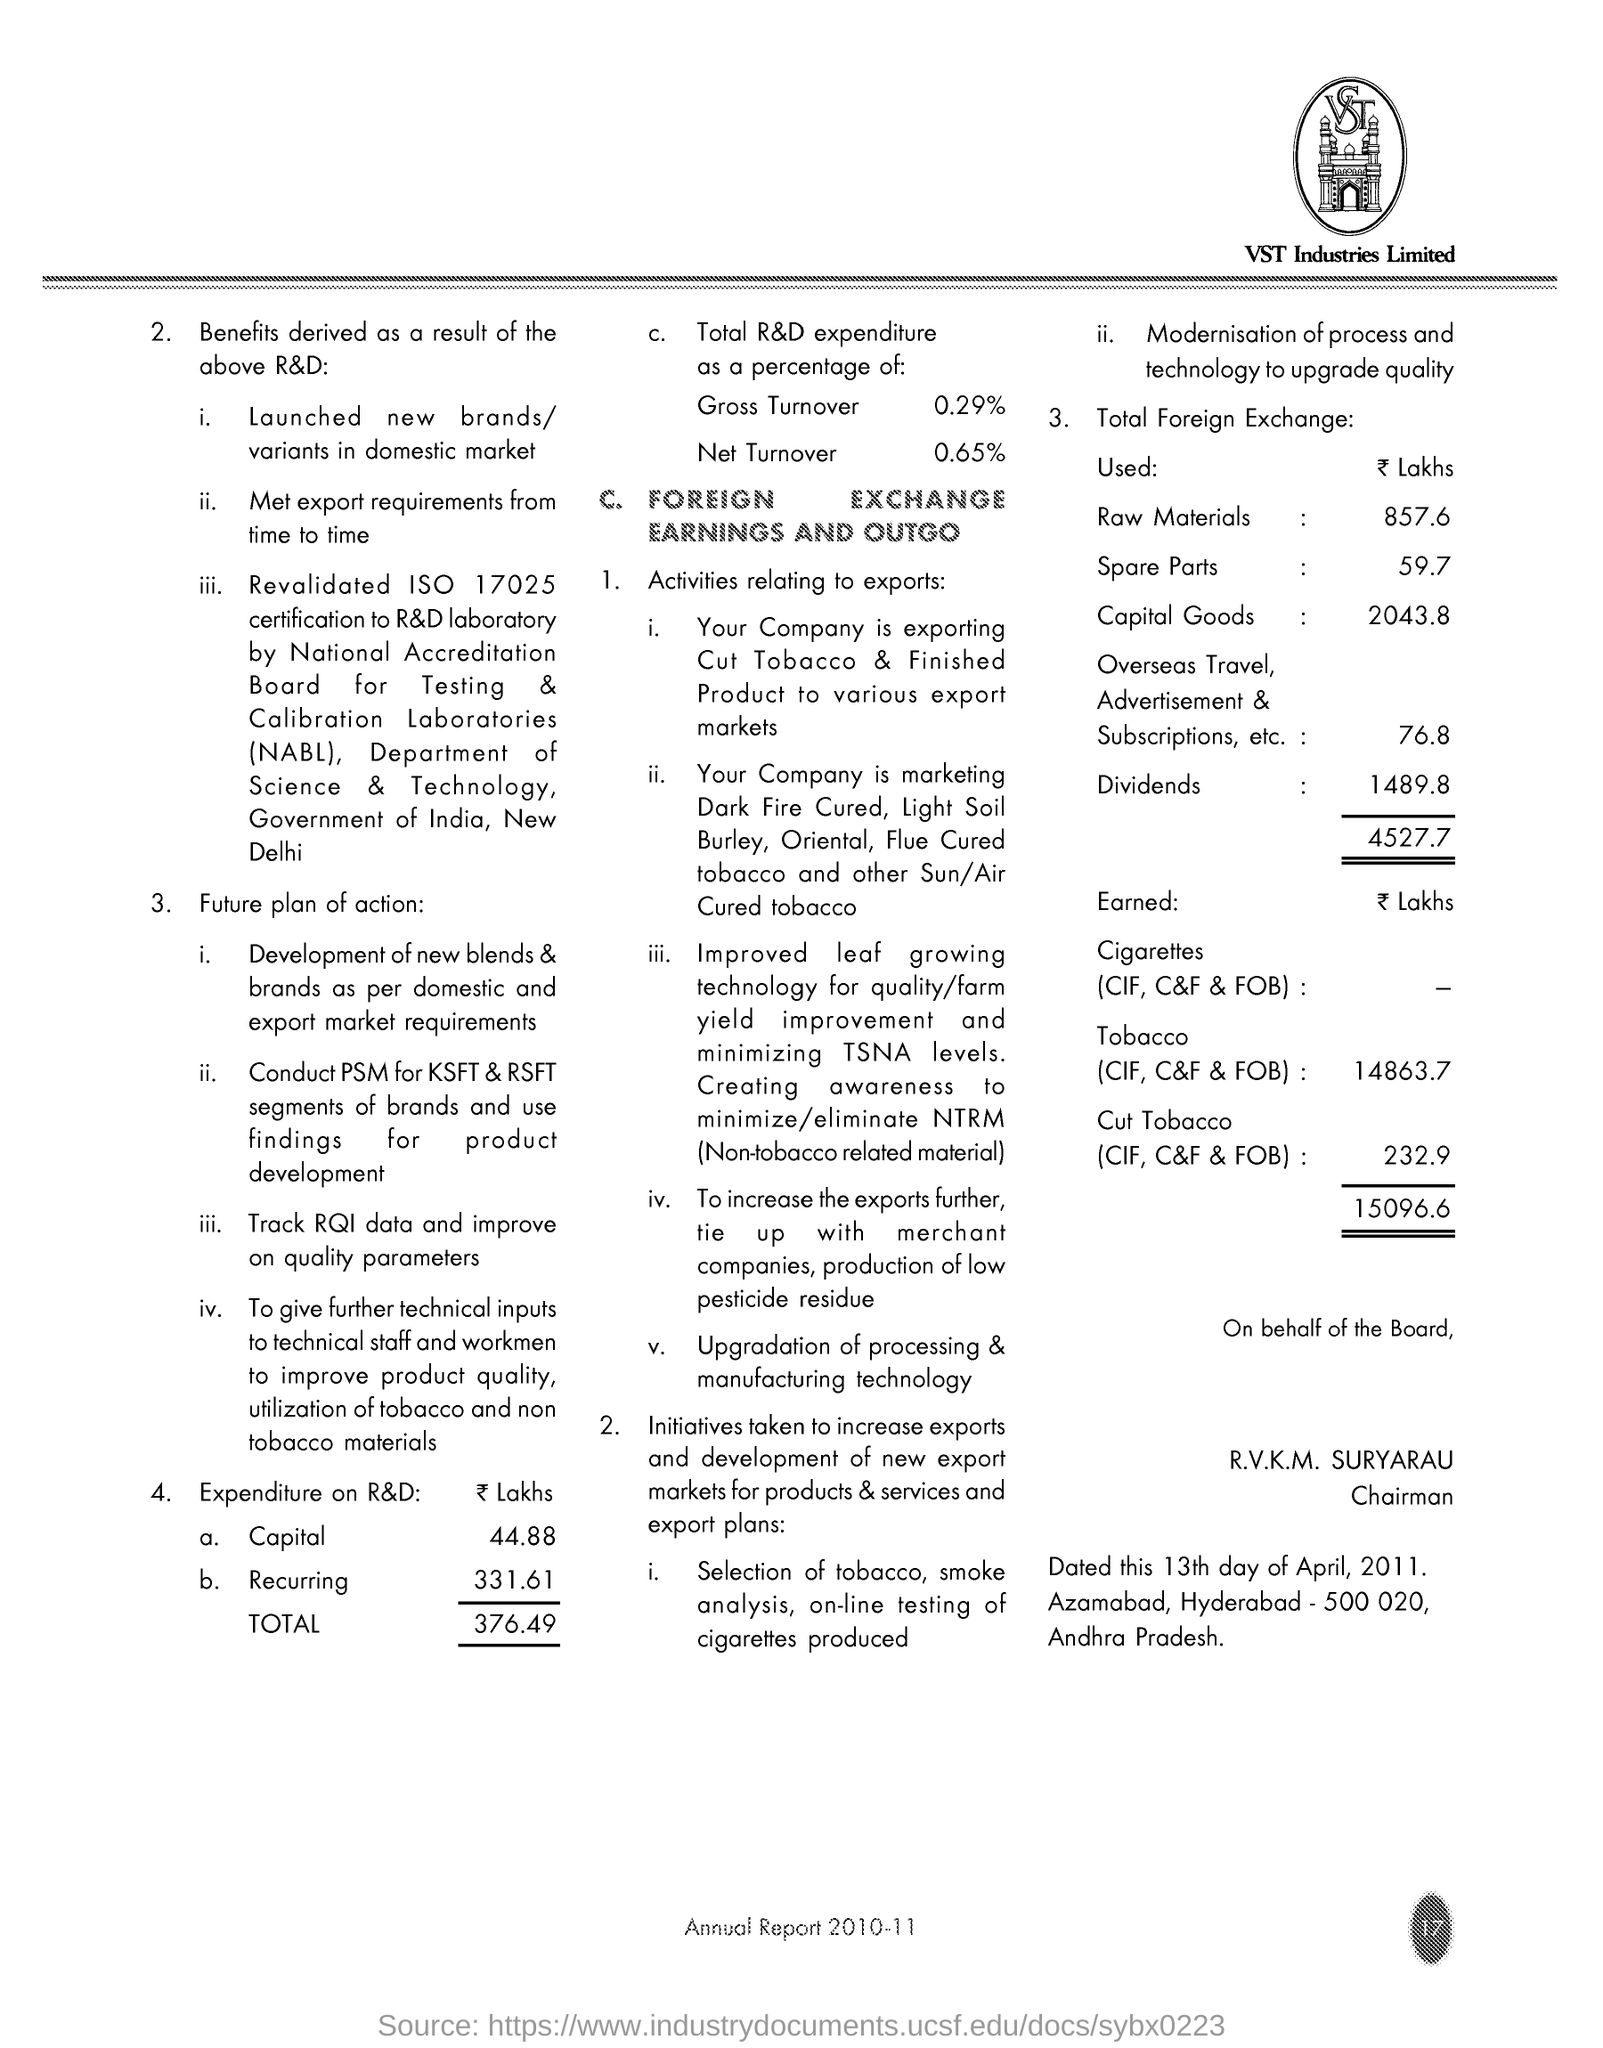Percentage of gross turnover?
Provide a short and direct response. 0.29%. Percentage of net turnover?
Give a very brief answer. 0.65. What is total expenditure in lakhs?
Keep it short and to the point. 376.49. What is recurring expenditure ?
Your answer should be compact. 331.61. What is capital in lakhs?
Your answer should be compact. 44.88. What is ISO number revalidated
Keep it short and to the point. 17025. 